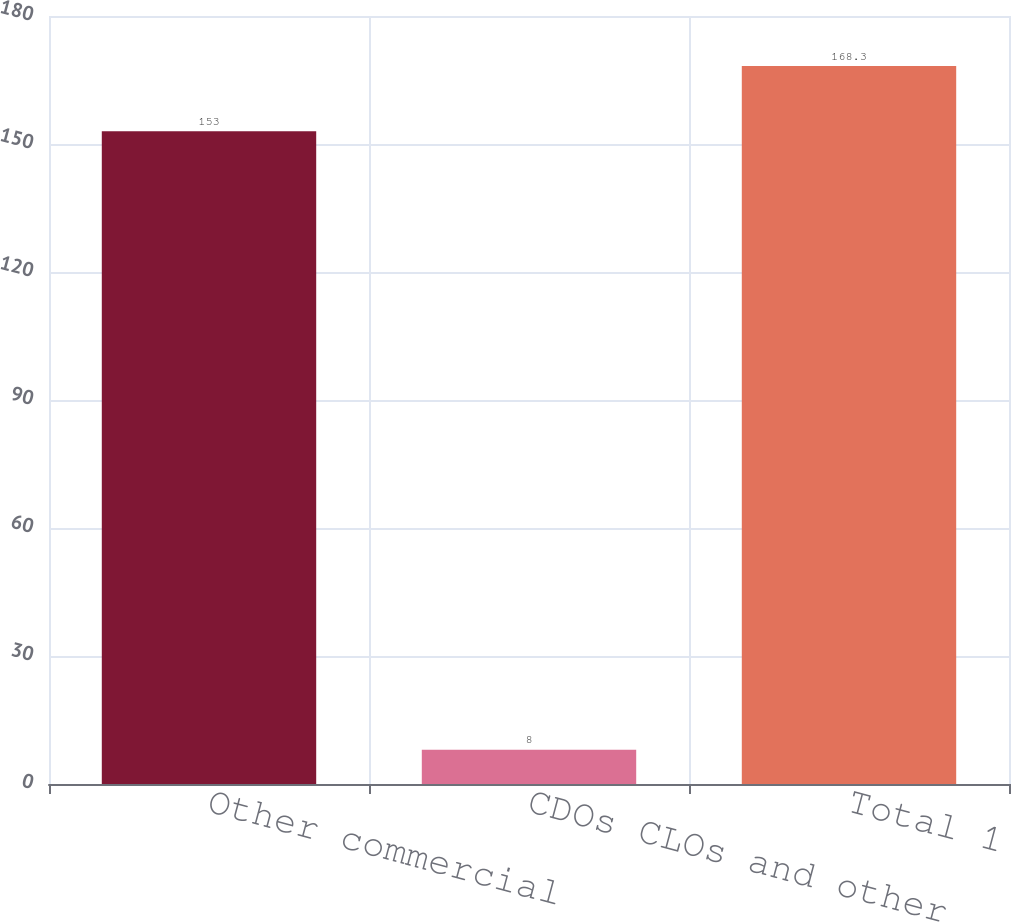Convert chart. <chart><loc_0><loc_0><loc_500><loc_500><bar_chart><fcel>Other commercial<fcel>CDOs CLOs and other<fcel>Total 1<nl><fcel>153<fcel>8<fcel>168.3<nl></chart> 